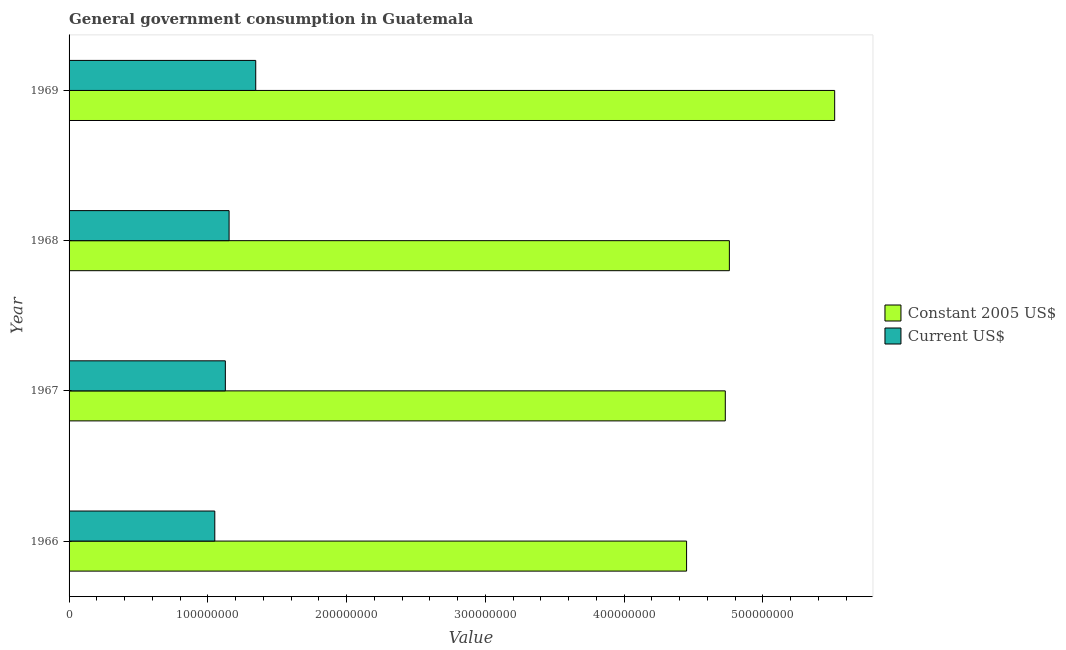Are the number of bars per tick equal to the number of legend labels?
Give a very brief answer. Yes. What is the label of the 2nd group of bars from the top?
Ensure brevity in your answer.  1968. In how many cases, is the number of bars for a given year not equal to the number of legend labels?
Offer a very short reply. 0. What is the value consumed in constant 2005 us$ in 1969?
Provide a short and direct response. 5.52e+08. Across all years, what is the maximum value consumed in constant 2005 us$?
Your answer should be compact. 5.52e+08. Across all years, what is the minimum value consumed in constant 2005 us$?
Your answer should be very brief. 4.45e+08. In which year was the value consumed in current us$ maximum?
Your answer should be very brief. 1969. In which year was the value consumed in current us$ minimum?
Provide a short and direct response. 1966. What is the total value consumed in constant 2005 us$ in the graph?
Ensure brevity in your answer.  1.95e+09. What is the difference between the value consumed in constant 2005 us$ in 1966 and that in 1967?
Your answer should be compact. -2.79e+07. What is the difference between the value consumed in constant 2005 us$ in 1967 and the value consumed in current us$ in 1968?
Your answer should be compact. 3.58e+08. What is the average value consumed in constant 2005 us$ per year?
Ensure brevity in your answer.  4.86e+08. In the year 1966, what is the difference between the value consumed in constant 2005 us$ and value consumed in current us$?
Your answer should be compact. 3.40e+08. In how many years, is the value consumed in current us$ greater than 300000000 ?
Offer a terse response. 0. What is the ratio of the value consumed in constant 2005 us$ in 1967 to that in 1968?
Make the answer very short. 0.99. Is the value consumed in constant 2005 us$ in 1966 less than that in 1968?
Your answer should be compact. Yes. What is the difference between the highest and the second highest value consumed in current us$?
Ensure brevity in your answer.  1.92e+07. What is the difference between the highest and the lowest value consumed in constant 2005 us$?
Make the answer very short. 1.07e+08. In how many years, is the value consumed in current us$ greater than the average value consumed in current us$ taken over all years?
Make the answer very short. 1. Is the sum of the value consumed in current us$ in 1967 and 1969 greater than the maximum value consumed in constant 2005 us$ across all years?
Your answer should be compact. No. What does the 2nd bar from the top in 1967 represents?
Provide a succinct answer. Constant 2005 US$. What does the 2nd bar from the bottom in 1966 represents?
Give a very brief answer. Current US$. Are all the bars in the graph horizontal?
Provide a short and direct response. Yes. How many years are there in the graph?
Make the answer very short. 4. What is the difference between two consecutive major ticks on the X-axis?
Make the answer very short. 1.00e+08. Are the values on the major ticks of X-axis written in scientific E-notation?
Keep it short and to the point. No. How are the legend labels stacked?
Provide a short and direct response. Vertical. What is the title of the graph?
Ensure brevity in your answer.  General government consumption in Guatemala. Does "Female population" appear as one of the legend labels in the graph?
Offer a very short reply. No. What is the label or title of the X-axis?
Keep it short and to the point. Value. What is the label or title of the Y-axis?
Provide a succinct answer. Year. What is the Value of Constant 2005 US$ in 1966?
Make the answer very short. 4.45e+08. What is the Value of Current US$ in 1966?
Ensure brevity in your answer.  1.05e+08. What is the Value in Constant 2005 US$ in 1967?
Your answer should be very brief. 4.73e+08. What is the Value in Current US$ in 1967?
Make the answer very short. 1.13e+08. What is the Value of Constant 2005 US$ in 1968?
Make the answer very short. 4.76e+08. What is the Value in Current US$ in 1968?
Keep it short and to the point. 1.15e+08. What is the Value in Constant 2005 US$ in 1969?
Offer a terse response. 5.52e+08. What is the Value of Current US$ in 1969?
Your response must be concise. 1.34e+08. Across all years, what is the maximum Value in Constant 2005 US$?
Offer a terse response. 5.52e+08. Across all years, what is the maximum Value of Current US$?
Provide a short and direct response. 1.34e+08. Across all years, what is the minimum Value in Constant 2005 US$?
Make the answer very short. 4.45e+08. Across all years, what is the minimum Value in Current US$?
Make the answer very short. 1.05e+08. What is the total Value in Constant 2005 US$ in the graph?
Your answer should be compact. 1.95e+09. What is the total Value of Current US$ in the graph?
Keep it short and to the point. 4.67e+08. What is the difference between the Value of Constant 2005 US$ in 1966 and that in 1967?
Provide a short and direct response. -2.79e+07. What is the difference between the Value in Current US$ in 1966 and that in 1967?
Make the answer very short. -7.60e+06. What is the difference between the Value of Constant 2005 US$ in 1966 and that in 1968?
Your response must be concise. -3.08e+07. What is the difference between the Value of Current US$ in 1966 and that in 1968?
Ensure brevity in your answer.  -1.03e+07. What is the difference between the Value in Constant 2005 US$ in 1966 and that in 1969?
Ensure brevity in your answer.  -1.07e+08. What is the difference between the Value in Current US$ in 1966 and that in 1969?
Make the answer very short. -2.95e+07. What is the difference between the Value of Constant 2005 US$ in 1967 and that in 1968?
Provide a short and direct response. -2.94e+06. What is the difference between the Value in Current US$ in 1967 and that in 1968?
Provide a succinct answer. -2.70e+06. What is the difference between the Value in Constant 2005 US$ in 1967 and that in 1969?
Keep it short and to the point. -7.88e+07. What is the difference between the Value in Current US$ in 1967 and that in 1969?
Provide a short and direct response. -2.19e+07. What is the difference between the Value of Constant 2005 US$ in 1968 and that in 1969?
Make the answer very short. -7.59e+07. What is the difference between the Value in Current US$ in 1968 and that in 1969?
Provide a succinct answer. -1.92e+07. What is the difference between the Value in Constant 2005 US$ in 1966 and the Value in Current US$ in 1967?
Make the answer very short. 3.32e+08. What is the difference between the Value in Constant 2005 US$ in 1966 and the Value in Current US$ in 1968?
Keep it short and to the point. 3.30e+08. What is the difference between the Value of Constant 2005 US$ in 1966 and the Value of Current US$ in 1969?
Provide a succinct answer. 3.10e+08. What is the difference between the Value in Constant 2005 US$ in 1967 and the Value in Current US$ in 1968?
Ensure brevity in your answer.  3.58e+08. What is the difference between the Value in Constant 2005 US$ in 1967 and the Value in Current US$ in 1969?
Keep it short and to the point. 3.38e+08. What is the difference between the Value of Constant 2005 US$ in 1968 and the Value of Current US$ in 1969?
Provide a short and direct response. 3.41e+08. What is the average Value in Constant 2005 US$ per year?
Offer a very short reply. 4.86e+08. What is the average Value in Current US$ per year?
Your answer should be compact. 1.17e+08. In the year 1966, what is the difference between the Value of Constant 2005 US$ and Value of Current US$?
Your answer should be very brief. 3.40e+08. In the year 1967, what is the difference between the Value of Constant 2005 US$ and Value of Current US$?
Make the answer very short. 3.60e+08. In the year 1968, what is the difference between the Value in Constant 2005 US$ and Value in Current US$?
Offer a terse response. 3.60e+08. In the year 1969, what is the difference between the Value of Constant 2005 US$ and Value of Current US$?
Provide a short and direct response. 4.17e+08. What is the ratio of the Value in Constant 2005 US$ in 1966 to that in 1967?
Keep it short and to the point. 0.94. What is the ratio of the Value in Current US$ in 1966 to that in 1967?
Give a very brief answer. 0.93. What is the ratio of the Value in Constant 2005 US$ in 1966 to that in 1968?
Offer a terse response. 0.94. What is the ratio of the Value of Current US$ in 1966 to that in 1968?
Offer a very short reply. 0.91. What is the ratio of the Value of Constant 2005 US$ in 1966 to that in 1969?
Offer a very short reply. 0.81. What is the ratio of the Value of Current US$ in 1966 to that in 1969?
Give a very brief answer. 0.78. What is the ratio of the Value of Current US$ in 1967 to that in 1968?
Provide a short and direct response. 0.98. What is the ratio of the Value in Current US$ in 1967 to that in 1969?
Provide a succinct answer. 0.84. What is the ratio of the Value of Constant 2005 US$ in 1968 to that in 1969?
Your answer should be compact. 0.86. What is the ratio of the Value in Current US$ in 1968 to that in 1969?
Make the answer very short. 0.86. What is the difference between the highest and the second highest Value in Constant 2005 US$?
Give a very brief answer. 7.59e+07. What is the difference between the highest and the second highest Value of Current US$?
Your answer should be very brief. 1.92e+07. What is the difference between the highest and the lowest Value of Constant 2005 US$?
Your answer should be very brief. 1.07e+08. What is the difference between the highest and the lowest Value of Current US$?
Your answer should be very brief. 2.95e+07. 